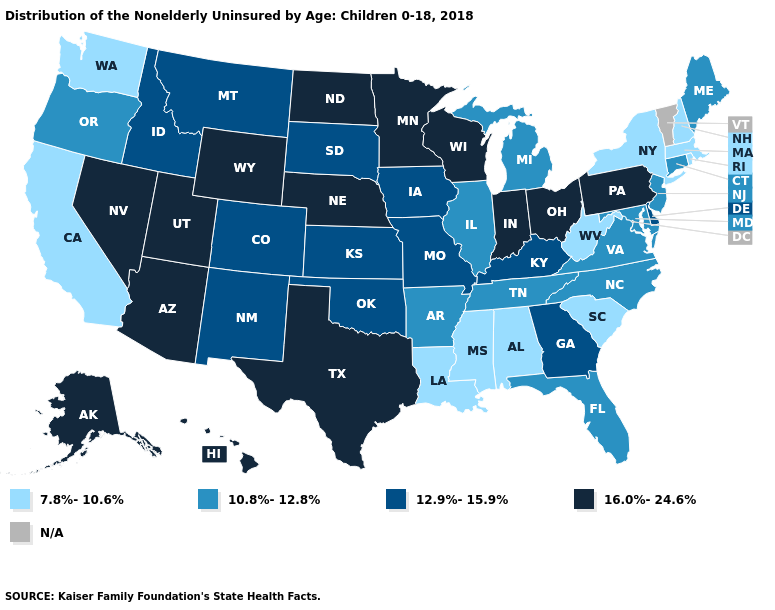Is the legend a continuous bar?
Be succinct. No. Name the states that have a value in the range 10.8%-12.8%?
Write a very short answer. Arkansas, Connecticut, Florida, Illinois, Maine, Maryland, Michigan, New Jersey, North Carolina, Oregon, Tennessee, Virginia. Name the states that have a value in the range 7.8%-10.6%?
Short answer required. Alabama, California, Louisiana, Massachusetts, Mississippi, New Hampshire, New York, Rhode Island, South Carolina, Washington, West Virginia. Does Arkansas have the lowest value in the South?
Write a very short answer. No. Name the states that have a value in the range 7.8%-10.6%?
Quick response, please. Alabama, California, Louisiana, Massachusetts, Mississippi, New Hampshire, New York, Rhode Island, South Carolina, Washington, West Virginia. How many symbols are there in the legend?
Answer briefly. 5. Name the states that have a value in the range 12.9%-15.9%?
Short answer required. Colorado, Delaware, Georgia, Idaho, Iowa, Kansas, Kentucky, Missouri, Montana, New Mexico, Oklahoma, South Dakota. Which states hav the highest value in the West?
Answer briefly. Alaska, Arizona, Hawaii, Nevada, Utah, Wyoming. What is the value of California?
Be succinct. 7.8%-10.6%. Does New Mexico have the lowest value in the West?
Short answer required. No. Does Texas have the highest value in the South?
Keep it brief. Yes. What is the value of Nevada?
Quick response, please. 16.0%-24.6%. What is the value of Idaho?
Short answer required. 12.9%-15.9%. Does Mississippi have the lowest value in the South?
Write a very short answer. Yes. Name the states that have a value in the range 16.0%-24.6%?
Give a very brief answer. Alaska, Arizona, Hawaii, Indiana, Minnesota, Nebraska, Nevada, North Dakota, Ohio, Pennsylvania, Texas, Utah, Wisconsin, Wyoming. 